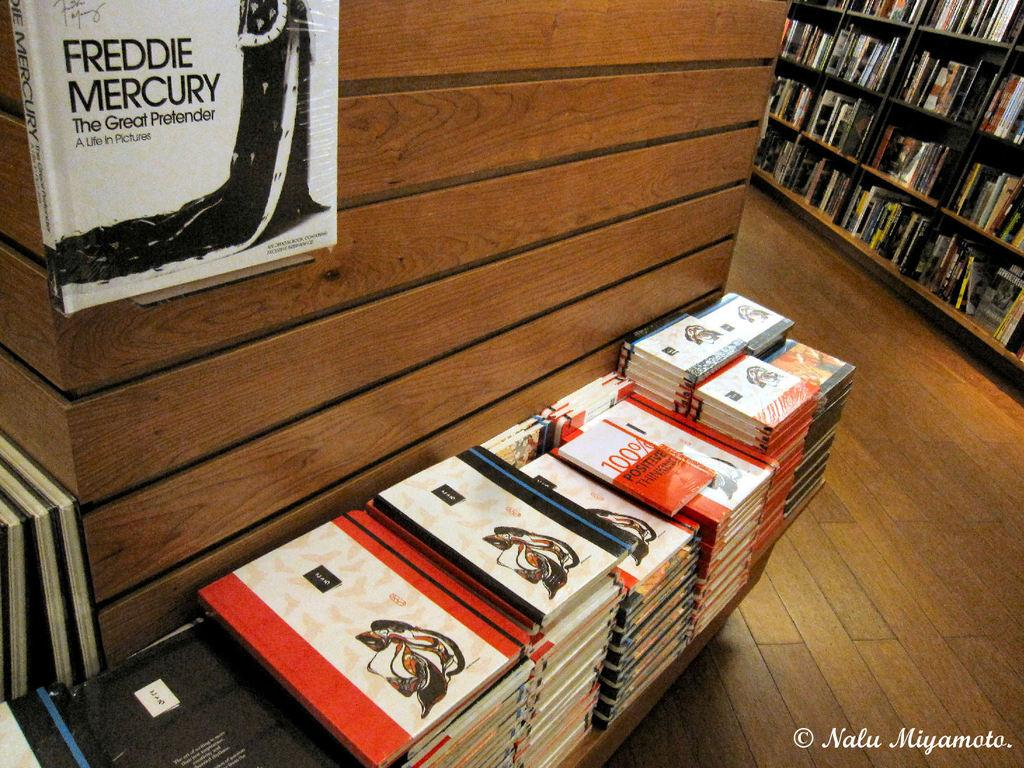<image>
Give a short and clear explanation of the subsequent image. A room with several stacks of books in front of a book above with the title Freddy Mercury. 